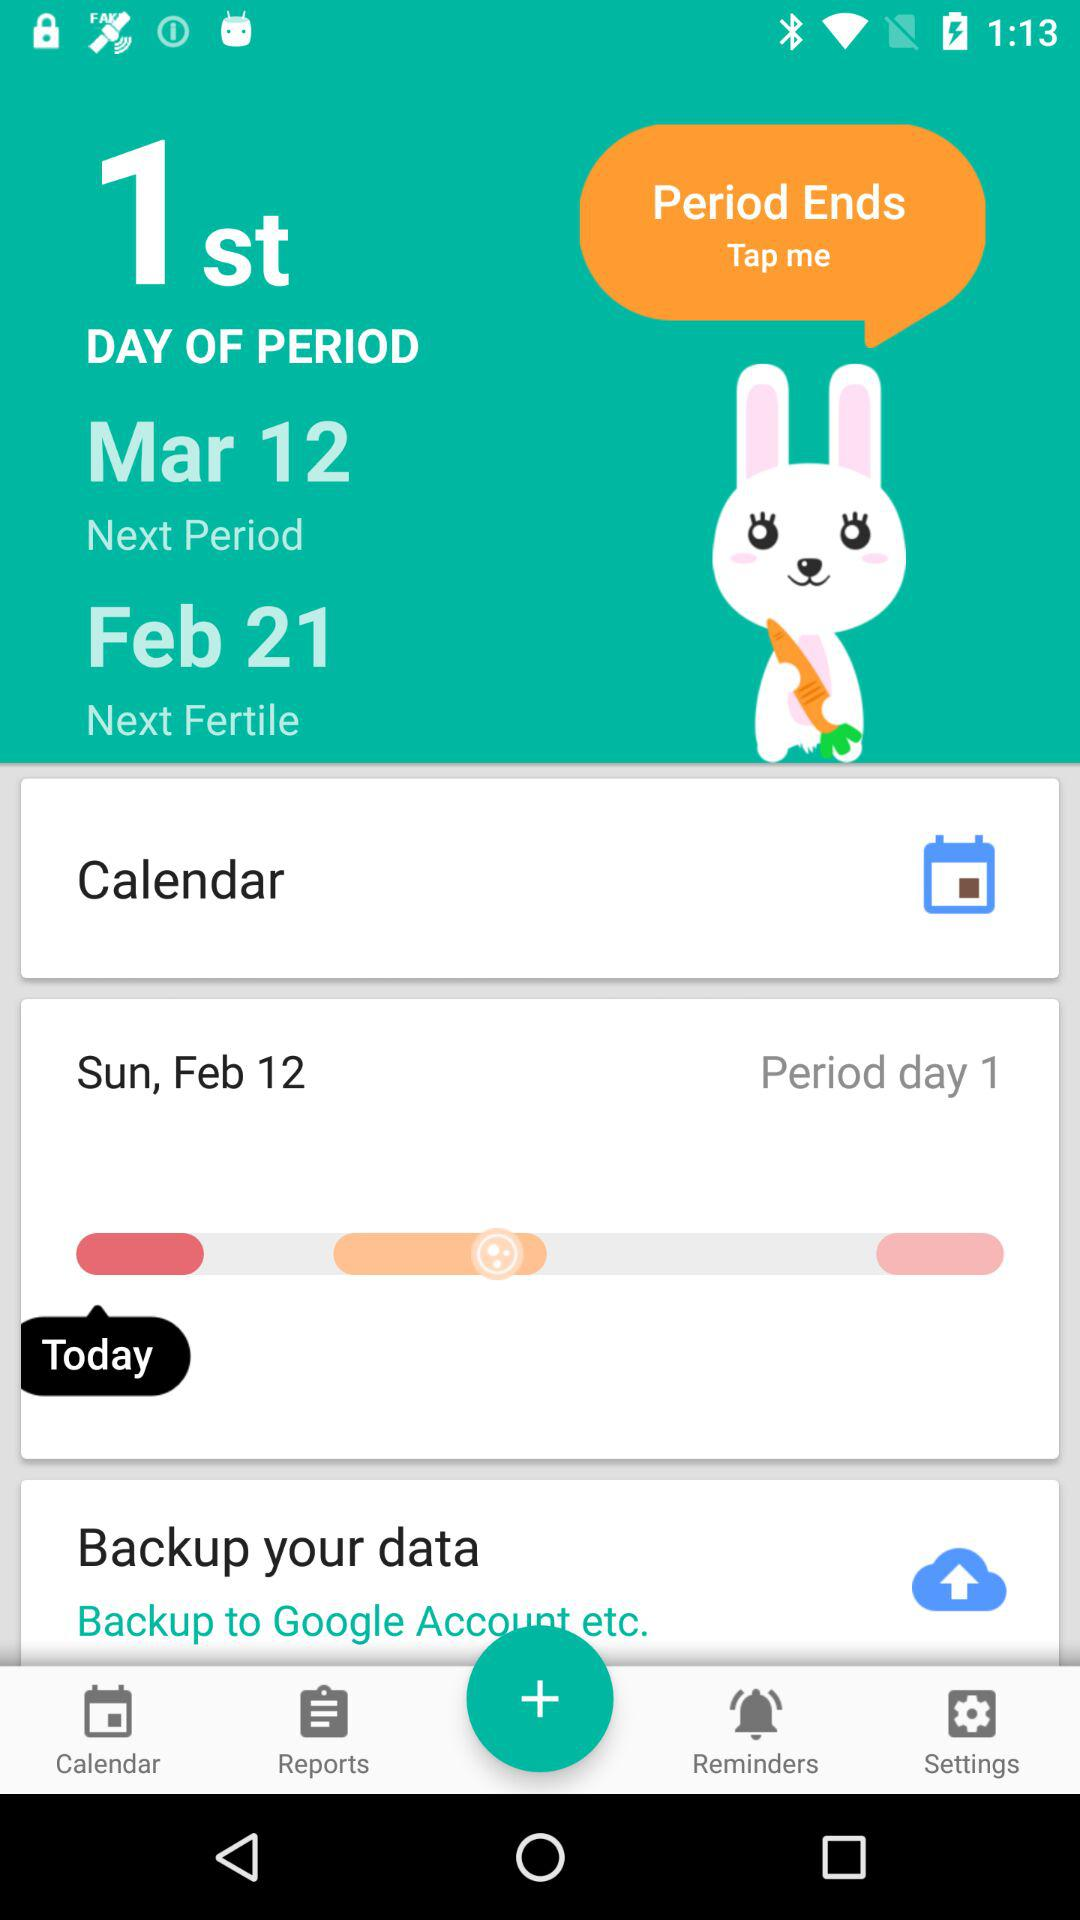What is the first day of period in February? The first day of period in February is Sunday, February 12. 